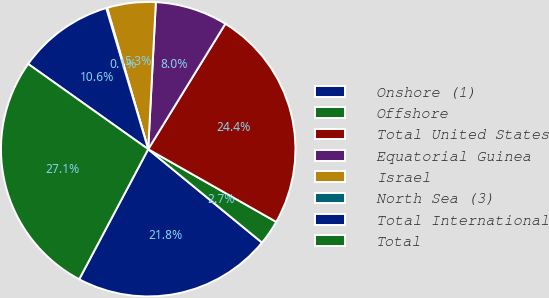Convert chart to OTSL. <chart><loc_0><loc_0><loc_500><loc_500><pie_chart><fcel>Onshore (1)<fcel>Offshore<fcel>Total United States<fcel>Equatorial Guinea<fcel>Israel<fcel>North Sea (3)<fcel>Total International<fcel>Total<nl><fcel>21.82%<fcel>2.72%<fcel>24.44%<fcel>7.95%<fcel>5.33%<fcel>0.1%<fcel>10.57%<fcel>27.06%<nl></chart> 